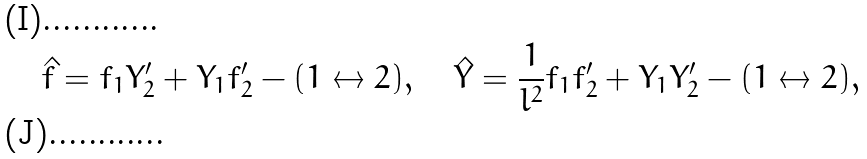<formula> <loc_0><loc_0><loc_500><loc_500>\hat { f } = f _ { 1 } Y ^ { \prime } _ { 2 } + Y _ { 1 } f _ { 2 } ^ { \prime } - ( 1 \leftrightarrow 2 ) , \quad \hat { Y } = \frac { 1 } { l ^ { 2 } } f _ { 1 } f ^ { \prime } _ { 2 } + Y _ { 1 } Y _ { 2 } ^ { \prime } - ( 1 \leftrightarrow 2 ) , \\</formula> 